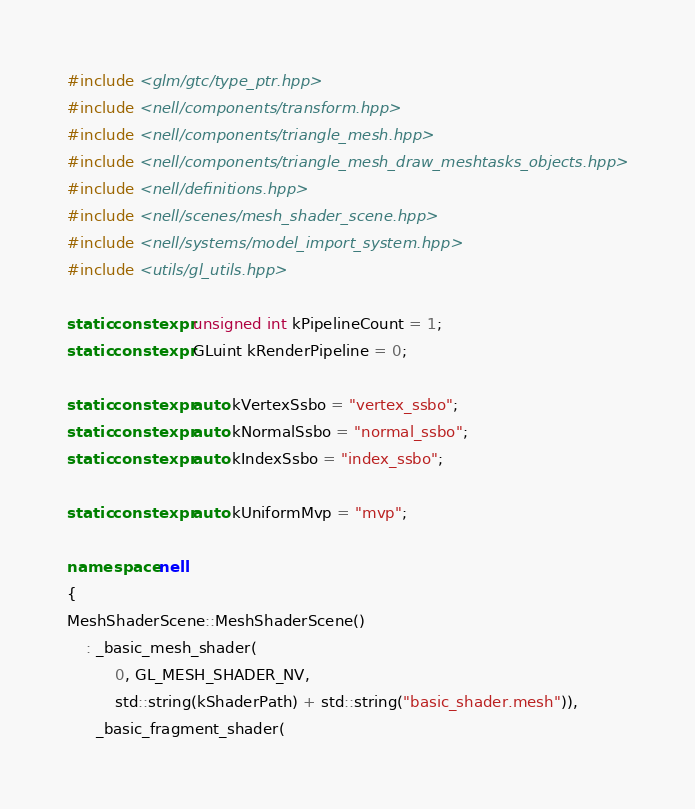Convert code to text. <code><loc_0><loc_0><loc_500><loc_500><_C++_>#include <glm/gtc/type_ptr.hpp>
#include <nell/components/transform.hpp>
#include <nell/components/triangle_mesh.hpp>
#include <nell/components/triangle_mesh_draw_meshtasks_objects.hpp>
#include <nell/definitions.hpp>
#include <nell/scenes/mesh_shader_scene.hpp>
#include <nell/systems/model_import_system.hpp>
#include <utils/gl_utils.hpp>

static constexpr unsigned int kPipelineCount = 1;
static constexpr GLuint kRenderPipeline = 0;

static constexpr auto kVertexSsbo = "vertex_ssbo";
static constexpr auto kNormalSsbo = "normal_ssbo";
static constexpr auto kIndexSsbo = "index_ssbo";

static constexpr auto kUniformMvp = "mvp";

namespace nell
{
MeshShaderScene::MeshShaderScene()
    : _basic_mesh_shader(
          0, GL_MESH_SHADER_NV,
          std::string(kShaderPath) + std::string("basic_shader.mesh")),
      _basic_fragment_shader(</code> 